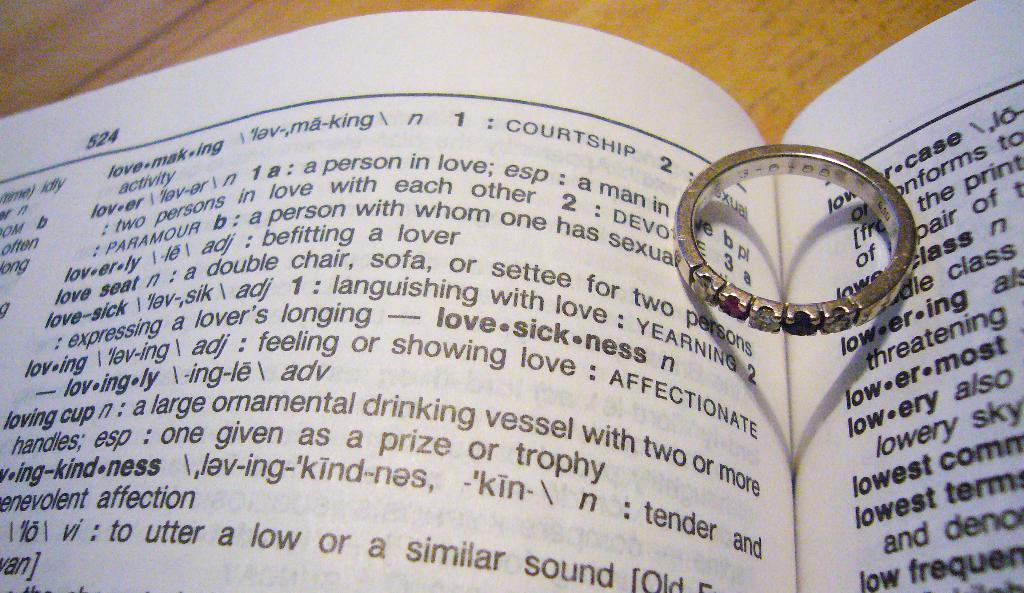Provide a one-sentence caption for the provided image. A book that has the work lovesickness in bold next to a wedding ring. 